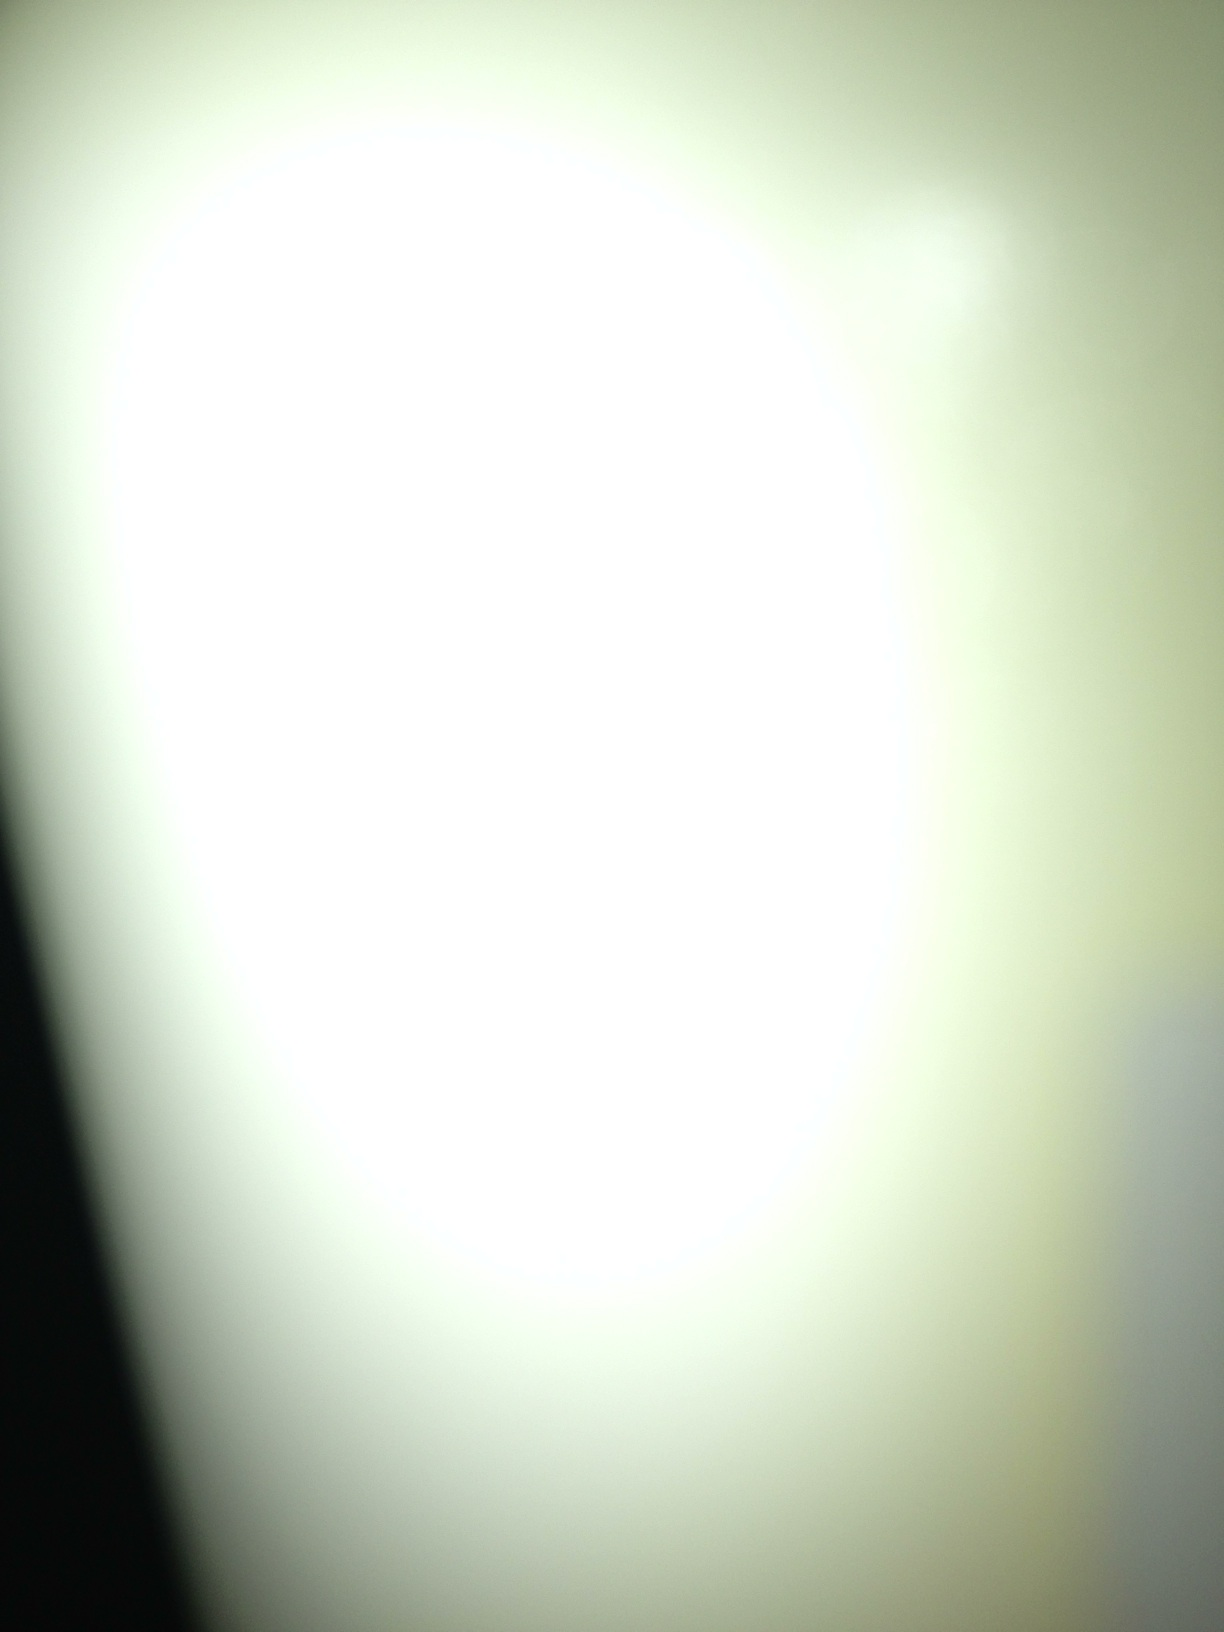What do you think this abstract image could represent? This abstract image could represent many things depending on one's perspective. It might symbolize the blinding nature of enlightenment or an intense focus of energy. The gradient from bright to dark could indicate a journey from clarity to obscurity, or vice versa. 